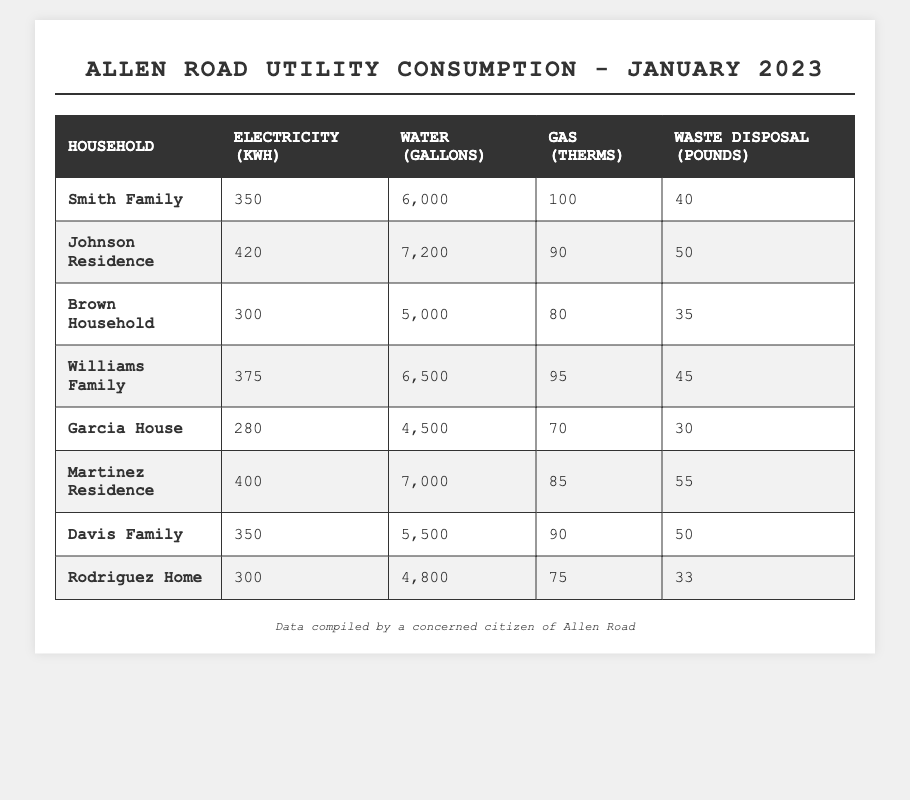What is the total amount of electricity consumed by all households on Allen Road? To find the total electricity consumption, we sum the electricity usage for each household: 350 + 420 + 300 + 375 + 280 + 400 + 350 + 300 = 2,075 kWh
Answer: 2075 kWh Which household used the most water in January 2023? The household with the highest water usage is found by comparing all the water consumption values: 6,000 (Smith) < 7,200 (Johnson) > 5,000 (Brown) < 6,500 (Williams) < 4,500 (Garcia) < 7,000 (Martinez) < 5,500 (Davis) < 4,800 (Rodriguez). Johnson Residence used the most water.
Answer: Johnson Residence How much more waste did the Martinez Residence dispose of compared to the Garcia House? To find the difference in waste disposal, we subtract the waste disposal of Garcia House from that of Martinez Residence: 55 (Martinez) - 30 (Garcia) = 25 pounds
Answer: 25 pounds Is the average gas consumption among all households greater than 85 therms? First, we calculate the average gas consumption by summing the gas usage: 100 + 90 + 80 + 95 + 70 + 85 + 90 + 75 = 700 therms, then divide by the number of households (8): 700 / 8 = 87.5 therms. Since 87.5 is greater than 85, the answer is yes.
Answer: Yes What is the median water usage among the households? First, we list the water usage in ascending order: 4,500 (Garcia), 4,800 (Rodriguez), 5,000 (Brown), 5,500 (Davis), 6,000 (Smith), 6,500 (Williams), 7,000 (Martinez), 7,200 (Johnson). There are 8 values, which means the median is the average of the 4th and 5th values: (5,500 + 6,000) / 2 = 5,750 gallons
Answer: 5750 gallons Which household consumed the least amount of gas? By examining the gas consumption for each household: 100 (Smith), 90 (Johnson), 80 (Brown), 95 (Williams), 70 (Garcia), 85 (Martinez), 90 (Davis), 75 (Rodriguez), we find that Garcia House used the least gas.
Answer: Garcia House How many households used more than 350 kWh of electricity? The households that used over 350 kWh are Johnson (420), Williams (375), and Martinez (400). Counting them gives us a total of 3 households.
Answer: 3 households What is the total waste disposal of the Smith Family and Brown Household combined? To find the total waste disposal, we add the values for Smith Family (40 pounds) and Brown Household (35 pounds): 40 + 35 = 75 pounds.
Answer: 75 pounds Is it true that at least one household used less than 300 gallons of water? Upon analyzing the water consumption data, the lowest value is 4,500 gallons (Garcia House), which is greater than 300. Thus, the statement is false.
Answer: No 